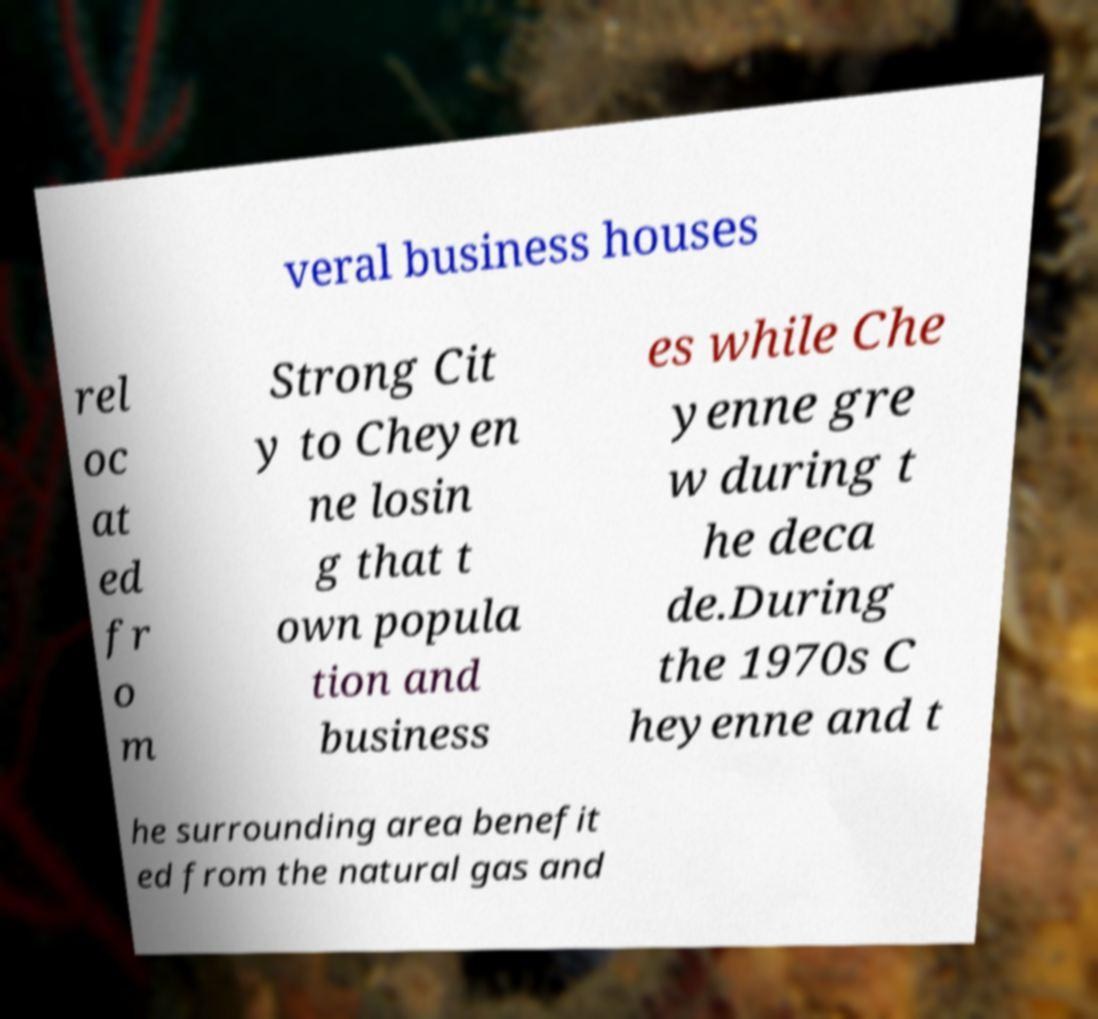Please identify and transcribe the text found in this image. veral business houses rel oc at ed fr o m Strong Cit y to Cheyen ne losin g that t own popula tion and business es while Che yenne gre w during t he deca de.During the 1970s C heyenne and t he surrounding area benefit ed from the natural gas and 